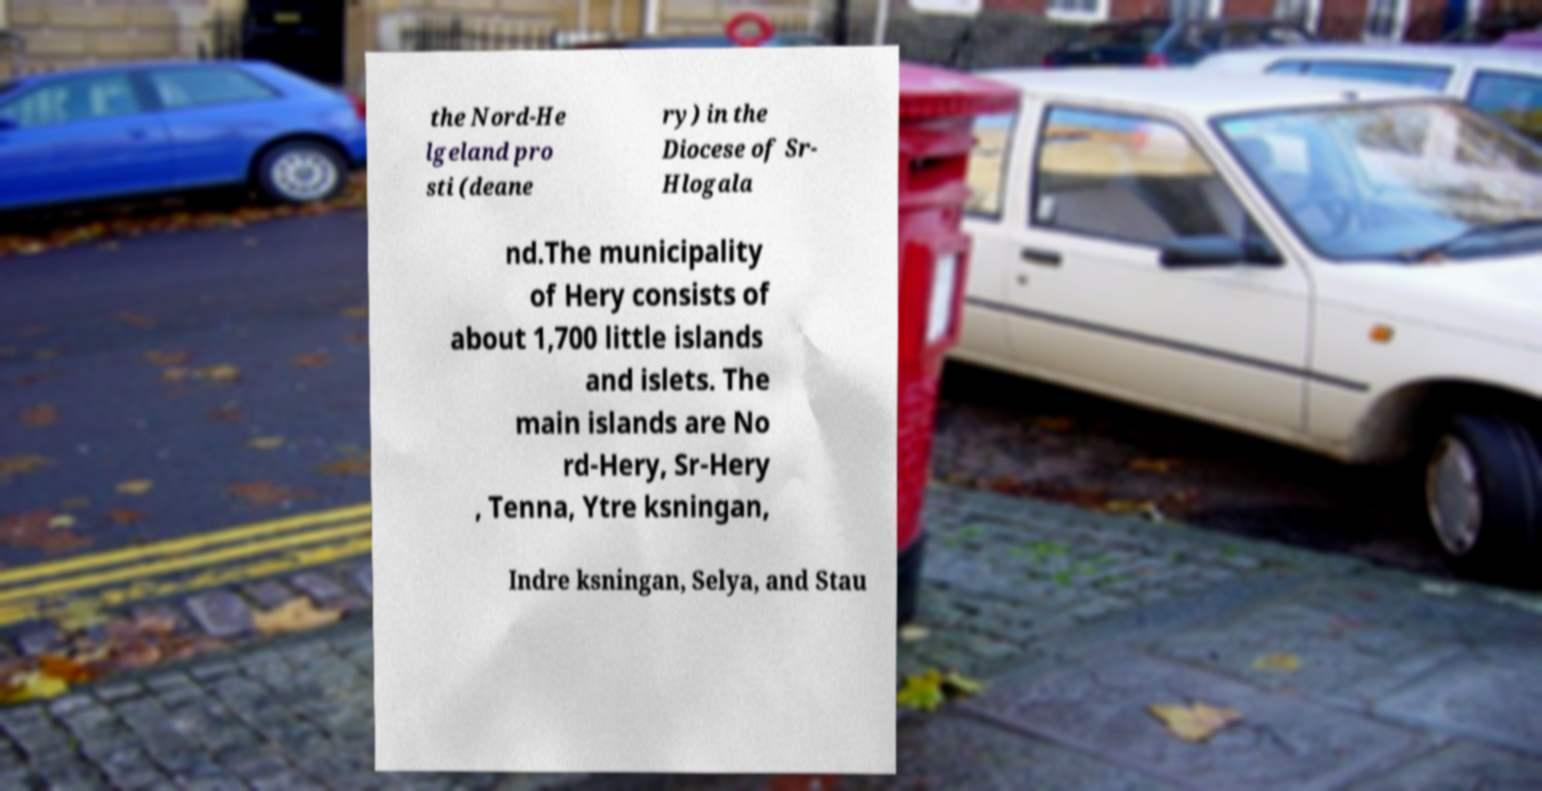I need the written content from this picture converted into text. Can you do that? the Nord-He lgeland pro sti (deane ry) in the Diocese of Sr- Hlogala nd.The municipality of Hery consists of about 1,700 little islands and islets. The main islands are No rd-Hery, Sr-Hery , Tenna, Ytre ksningan, Indre ksningan, Selya, and Stau 